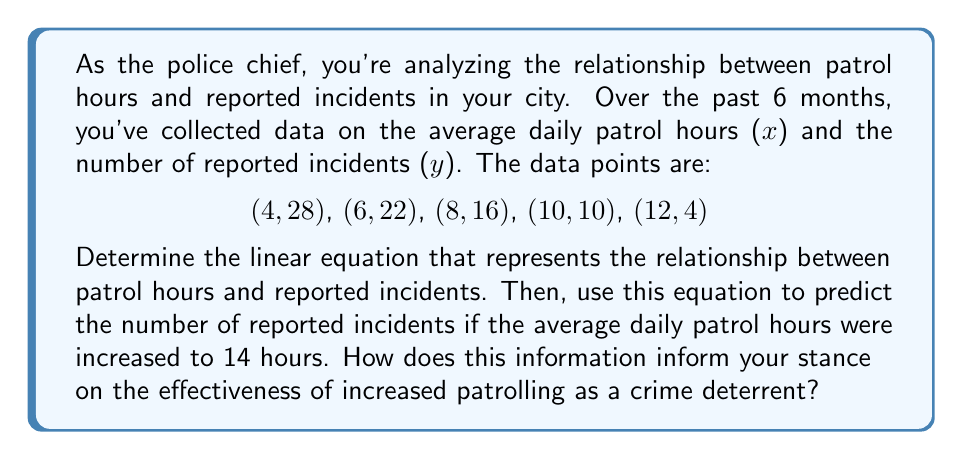What is the answer to this math problem? To determine the linear relationship between patrol hours and reported incidents, we'll use the slope-intercept form of a linear equation: $y = mx + b$, where $m$ is the slope and $b$ is the y-intercept.

1. Calculate the slope ($m$):
   We can use any two points to calculate the slope. Let's use (4, 28) and (12, 4).
   
   $m = \frac{y_2 - y_1}{x_2 - x_1} = \frac{4 - 28}{12 - 4} = \frac{-24}{8} = -3$

2. Find the y-intercept ($b$):
   Use the point-slope form of a line with the point (4, 28):
   
   $y - y_1 = m(x - x_1)$
   $y - 28 = -3(x - 4)$
   $y = -3x + 12 + 28$
   $y = -3x + 40$

3. The linear equation is:
   $y = -3x + 40$

4. To predict the number of reported incidents for 14 patrol hours:
   $y = -3(14) + 40 = -42 + 40 = -2$

   However, since we can't have a negative number of incidents, we would interpret this as approximately 0 incidents.

This equation shows that for each additional hour of patrolling, the number of reported incidents decreases by 3. The y-intercept of 40 represents the predicted number of incidents if there were no patrols.

The negative result for 14 patrol hours suggests that the model predicts the number of incidents would reach zero before 14 hours of patrolling, indicating diminishing returns for increased patrol hours beyond a certain point.
Answer: The linear equation is $y = -3x + 40$, where $x$ is the number of patrol hours and $y$ is the number of reported incidents. For 14 patrol hours, the model predicts approximately 0 reported incidents, suggesting that increasing patrol hours beyond the point where incidents reach zero may not be an effective use of resources. 